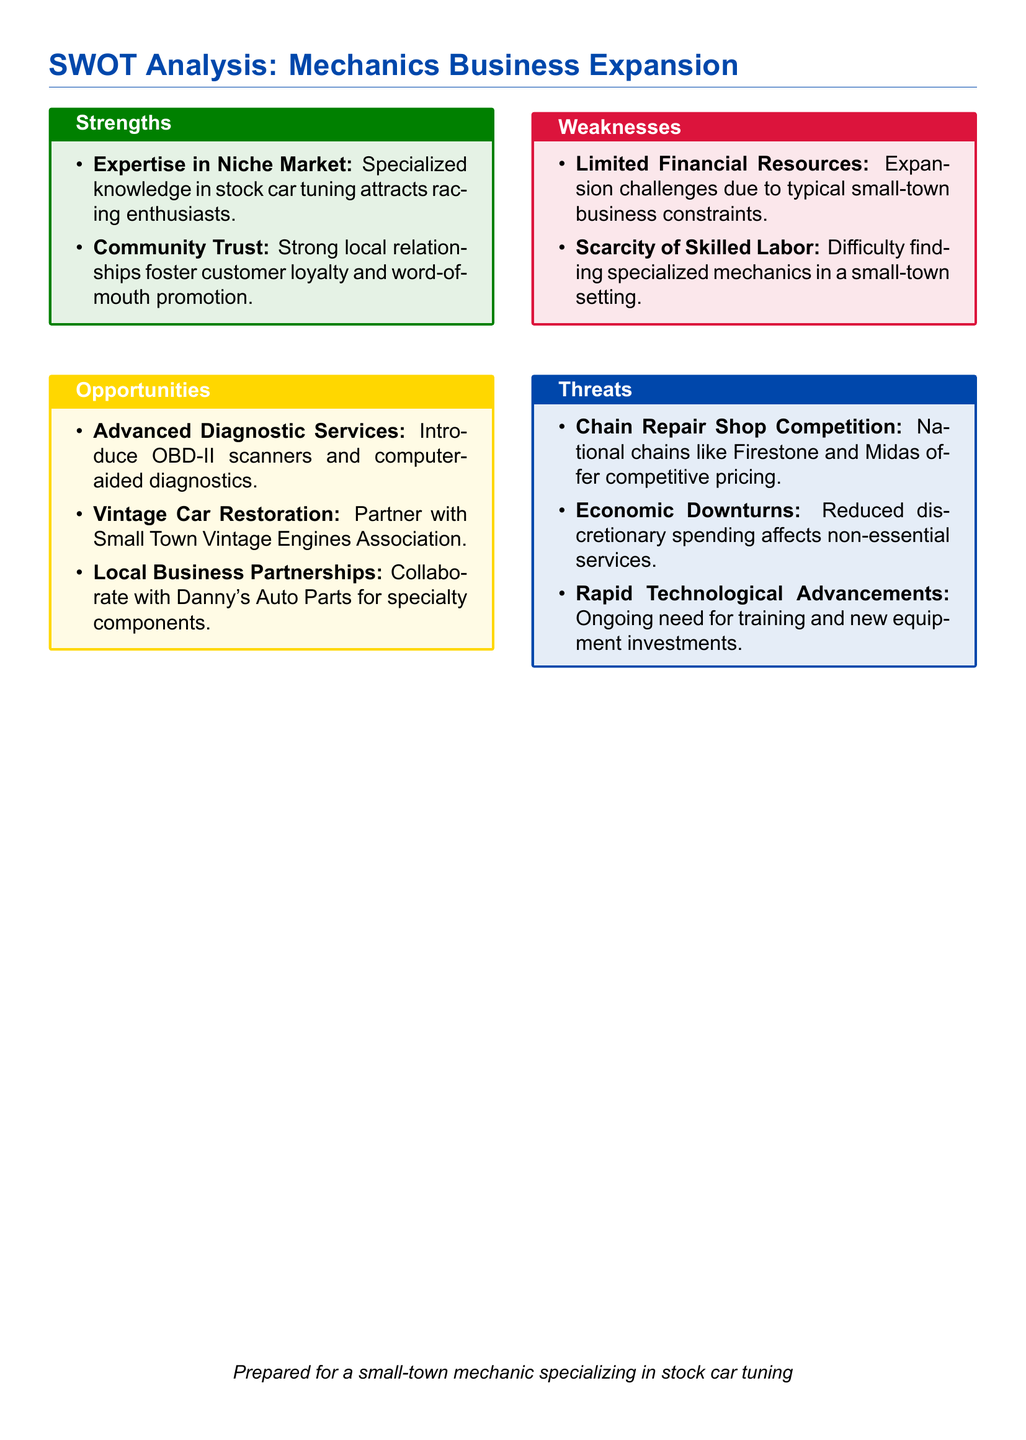What are the strengths listed in the SWOT analysis? The strengths are specific attributes that help the business, detailed in the "Strengths" section of the analysis.
Answer: Expertise in Niche Market, Community Trust What opportunity involves working with a local organization? This opportunity suggests potential collaboration with a local group, found in the "Opportunities" section.
Answer: Partner with Small Town Vintage Engines Association What is a threat mentioned regarding competition? This threat highlights external competition likely affecting the business, found in the "Threats" section.
Answer: Chain Repair Shop Competition How many weaknesses are identified in the analysis? The total number of weaknesses is quantified by counting the bullet points listed in the "Weaknesses" section.
Answer: 2 What service addition involves modern technology? This service addition relates to advanced tools for vehicle diagnostics, mentioned in the "Opportunities" section.
Answer: Advanced Diagnostic Services Which color represents the "Threats" section? The section color indicates how threats are visually categorized in the document.
Answer: Mechanic Red What financial challenge is noted as a weakness? This challenge is explicitly mentioned in the "Weaknesses" section to reflect business limitations.
Answer: Limited Financial Resources What local business is mentioned for potential collaboration? The specific local business that could partner is noted in the "Opportunities" section.
Answer: Danny's Auto Parts 